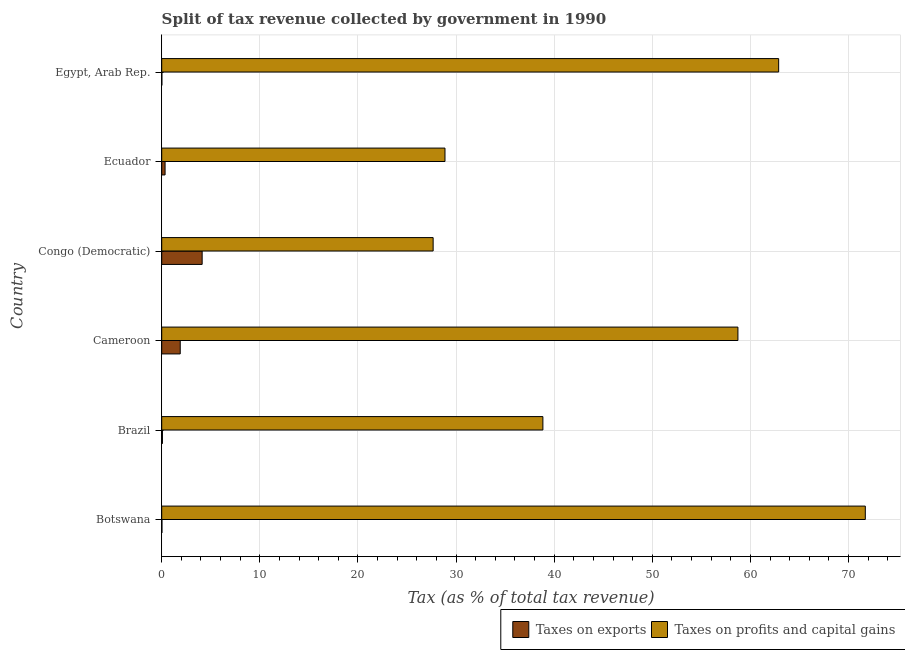Are the number of bars per tick equal to the number of legend labels?
Your answer should be very brief. Yes. How many bars are there on the 4th tick from the top?
Offer a very short reply. 2. What is the label of the 4th group of bars from the top?
Offer a very short reply. Cameroon. In how many cases, is the number of bars for a given country not equal to the number of legend labels?
Provide a succinct answer. 0. What is the percentage of revenue obtained from taxes on exports in Ecuador?
Provide a succinct answer. 0.34. Across all countries, what is the maximum percentage of revenue obtained from taxes on exports?
Your response must be concise. 4.12. Across all countries, what is the minimum percentage of revenue obtained from taxes on profits and capital gains?
Your answer should be very brief. 27.66. In which country was the percentage of revenue obtained from taxes on profits and capital gains maximum?
Your answer should be very brief. Botswana. In which country was the percentage of revenue obtained from taxes on exports minimum?
Provide a short and direct response. Egypt, Arab Rep. What is the total percentage of revenue obtained from taxes on profits and capital gains in the graph?
Ensure brevity in your answer.  288.69. What is the difference between the percentage of revenue obtained from taxes on exports in Congo (Democratic) and that in Ecuador?
Make the answer very short. 3.78. What is the difference between the percentage of revenue obtained from taxes on exports in Botswana and the percentage of revenue obtained from taxes on profits and capital gains in Ecuador?
Offer a terse response. -28.85. What is the average percentage of revenue obtained from taxes on exports per country?
Provide a succinct answer. 1.08. What is the difference between the percentage of revenue obtained from taxes on profits and capital gains and percentage of revenue obtained from taxes on exports in Congo (Democratic)?
Offer a terse response. 23.54. What is the ratio of the percentage of revenue obtained from taxes on profits and capital gains in Botswana to that in Congo (Democratic)?
Your response must be concise. 2.59. What is the difference between the highest and the second highest percentage of revenue obtained from taxes on exports?
Provide a succinct answer. 2.23. What is the difference between the highest and the lowest percentage of revenue obtained from taxes on profits and capital gains?
Your answer should be compact. 44.05. What does the 1st bar from the top in Egypt, Arab Rep. represents?
Provide a short and direct response. Taxes on profits and capital gains. What does the 1st bar from the bottom in Congo (Democratic) represents?
Ensure brevity in your answer.  Taxes on exports. Are all the bars in the graph horizontal?
Offer a terse response. Yes. How many countries are there in the graph?
Offer a very short reply. 6. What is the difference between two consecutive major ticks on the X-axis?
Provide a succinct answer. 10. Does the graph contain any zero values?
Your answer should be very brief. No. Where does the legend appear in the graph?
Provide a succinct answer. Bottom right. How many legend labels are there?
Give a very brief answer. 2. What is the title of the graph?
Your answer should be very brief. Split of tax revenue collected by government in 1990. What is the label or title of the X-axis?
Your answer should be compact. Tax (as % of total tax revenue). What is the label or title of the Y-axis?
Ensure brevity in your answer.  Country. What is the Tax (as % of total tax revenue) in Taxes on exports in Botswana?
Offer a very short reply. 0.02. What is the Tax (as % of total tax revenue) of Taxes on profits and capital gains in Botswana?
Provide a short and direct response. 71.71. What is the Tax (as % of total tax revenue) in Taxes on exports in Brazil?
Provide a short and direct response. 0.07. What is the Tax (as % of total tax revenue) of Taxes on profits and capital gains in Brazil?
Offer a terse response. 38.85. What is the Tax (as % of total tax revenue) of Taxes on exports in Cameroon?
Your answer should be compact. 1.89. What is the Tax (as % of total tax revenue) of Taxes on profits and capital gains in Cameroon?
Make the answer very short. 58.73. What is the Tax (as % of total tax revenue) of Taxes on exports in Congo (Democratic)?
Offer a terse response. 4.12. What is the Tax (as % of total tax revenue) in Taxes on profits and capital gains in Congo (Democratic)?
Give a very brief answer. 27.66. What is the Tax (as % of total tax revenue) in Taxes on exports in Ecuador?
Provide a succinct answer. 0.34. What is the Tax (as % of total tax revenue) in Taxes on profits and capital gains in Ecuador?
Provide a short and direct response. 28.87. What is the Tax (as % of total tax revenue) of Taxes on exports in Egypt, Arab Rep.?
Provide a succinct answer. 0.02. What is the Tax (as % of total tax revenue) of Taxes on profits and capital gains in Egypt, Arab Rep.?
Ensure brevity in your answer.  62.88. Across all countries, what is the maximum Tax (as % of total tax revenue) of Taxes on exports?
Provide a short and direct response. 4.12. Across all countries, what is the maximum Tax (as % of total tax revenue) in Taxes on profits and capital gains?
Offer a terse response. 71.71. Across all countries, what is the minimum Tax (as % of total tax revenue) in Taxes on exports?
Your response must be concise. 0.02. Across all countries, what is the minimum Tax (as % of total tax revenue) of Taxes on profits and capital gains?
Make the answer very short. 27.66. What is the total Tax (as % of total tax revenue) of Taxes on exports in the graph?
Make the answer very short. 6.46. What is the total Tax (as % of total tax revenue) in Taxes on profits and capital gains in the graph?
Your response must be concise. 288.69. What is the difference between the Tax (as % of total tax revenue) in Taxes on exports in Botswana and that in Brazil?
Your answer should be compact. -0.05. What is the difference between the Tax (as % of total tax revenue) in Taxes on profits and capital gains in Botswana and that in Brazil?
Your response must be concise. 32.86. What is the difference between the Tax (as % of total tax revenue) in Taxes on exports in Botswana and that in Cameroon?
Provide a short and direct response. -1.86. What is the difference between the Tax (as % of total tax revenue) in Taxes on profits and capital gains in Botswana and that in Cameroon?
Give a very brief answer. 12.98. What is the difference between the Tax (as % of total tax revenue) of Taxes on exports in Botswana and that in Congo (Democratic)?
Offer a terse response. -4.1. What is the difference between the Tax (as % of total tax revenue) in Taxes on profits and capital gains in Botswana and that in Congo (Democratic)?
Make the answer very short. 44.05. What is the difference between the Tax (as % of total tax revenue) in Taxes on exports in Botswana and that in Ecuador?
Give a very brief answer. -0.32. What is the difference between the Tax (as % of total tax revenue) in Taxes on profits and capital gains in Botswana and that in Ecuador?
Provide a short and direct response. 42.84. What is the difference between the Tax (as % of total tax revenue) of Taxes on exports in Botswana and that in Egypt, Arab Rep.?
Give a very brief answer. 0.01. What is the difference between the Tax (as % of total tax revenue) of Taxes on profits and capital gains in Botswana and that in Egypt, Arab Rep.?
Offer a terse response. 8.83. What is the difference between the Tax (as % of total tax revenue) of Taxes on exports in Brazil and that in Cameroon?
Make the answer very short. -1.81. What is the difference between the Tax (as % of total tax revenue) in Taxes on profits and capital gains in Brazil and that in Cameroon?
Give a very brief answer. -19.88. What is the difference between the Tax (as % of total tax revenue) of Taxes on exports in Brazil and that in Congo (Democratic)?
Your answer should be compact. -4.05. What is the difference between the Tax (as % of total tax revenue) in Taxes on profits and capital gains in Brazil and that in Congo (Democratic)?
Provide a succinct answer. 11.19. What is the difference between the Tax (as % of total tax revenue) in Taxes on exports in Brazil and that in Ecuador?
Your answer should be compact. -0.27. What is the difference between the Tax (as % of total tax revenue) in Taxes on profits and capital gains in Brazil and that in Ecuador?
Keep it short and to the point. 9.98. What is the difference between the Tax (as % of total tax revenue) in Taxes on exports in Brazil and that in Egypt, Arab Rep.?
Provide a short and direct response. 0.06. What is the difference between the Tax (as % of total tax revenue) in Taxes on profits and capital gains in Brazil and that in Egypt, Arab Rep.?
Keep it short and to the point. -24.03. What is the difference between the Tax (as % of total tax revenue) of Taxes on exports in Cameroon and that in Congo (Democratic)?
Your answer should be compact. -2.23. What is the difference between the Tax (as % of total tax revenue) in Taxes on profits and capital gains in Cameroon and that in Congo (Democratic)?
Provide a short and direct response. 31.06. What is the difference between the Tax (as % of total tax revenue) in Taxes on exports in Cameroon and that in Ecuador?
Ensure brevity in your answer.  1.54. What is the difference between the Tax (as % of total tax revenue) in Taxes on profits and capital gains in Cameroon and that in Ecuador?
Give a very brief answer. 29.86. What is the difference between the Tax (as % of total tax revenue) of Taxes on exports in Cameroon and that in Egypt, Arab Rep.?
Offer a very short reply. 1.87. What is the difference between the Tax (as % of total tax revenue) of Taxes on profits and capital gains in Cameroon and that in Egypt, Arab Rep.?
Offer a very short reply. -4.15. What is the difference between the Tax (as % of total tax revenue) in Taxes on exports in Congo (Democratic) and that in Ecuador?
Offer a very short reply. 3.78. What is the difference between the Tax (as % of total tax revenue) of Taxes on profits and capital gains in Congo (Democratic) and that in Ecuador?
Ensure brevity in your answer.  -1.21. What is the difference between the Tax (as % of total tax revenue) of Taxes on exports in Congo (Democratic) and that in Egypt, Arab Rep.?
Your answer should be compact. 4.11. What is the difference between the Tax (as % of total tax revenue) of Taxes on profits and capital gains in Congo (Democratic) and that in Egypt, Arab Rep.?
Your answer should be very brief. -35.21. What is the difference between the Tax (as % of total tax revenue) of Taxes on exports in Ecuador and that in Egypt, Arab Rep.?
Offer a terse response. 0.33. What is the difference between the Tax (as % of total tax revenue) of Taxes on profits and capital gains in Ecuador and that in Egypt, Arab Rep.?
Give a very brief answer. -34.01. What is the difference between the Tax (as % of total tax revenue) in Taxes on exports in Botswana and the Tax (as % of total tax revenue) in Taxes on profits and capital gains in Brazil?
Give a very brief answer. -38.83. What is the difference between the Tax (as % of total tax revenue) of Taxes on exports in Botswana and the Tax (as % of total tax revenue) of Taxes on profits and capital gains in Cameroon?
Your response must be concise. -58.7. What is the difference between the Tax (as % of total tax revenue) in Taxes on exports in Botswana and the Tax (as % of total tax revenue) in Taxes on profits and capital gains in Congo (Democratic)?
Make the answer very short. -27.64. What is the difference between the Tax (as % of total tax revenue) of Taxes on exports in Botswana and the Tax (as % of total tax revenue) of Taxes on profits and capital gains in Ecuador?
Offer a very short reply. -28.85. What is the difference between the Tax (as % of total tax revenue) in Taxes on exports in Botswana and the Tax (as % of total tax revenue) in Taxes on profits and capital gains in Egypt, Arab Rep.?
Offer a very short reply. -62.85. What is the difference between the Tax (as % of total tax revenue) of Taxes on exports in Brazil and the Tax (as % of total tax revenue) of Taxes on profits and capital gains in Cameroon?
Offer a terse response. -58.65. What is the difference between the Tax (as % of total tax revenue) in Taxes on exports in Brazil and the Tax (as % of total tax revenue) in Taxes on profits and capital gains in Congo (Democratic)?
Make the answer very short. -27.59. What is the difference between the Tax (as % of total tax revenue) of Taxes on exports in Brazil and the Tax (as % of total tax revenue) of Taxes on profits and capital gains in Ecuador?
Provide a succinct answer. -28.8. What is the difference between the Tax (as % of total tax revenue) in Taxes on exports in Brazil and the Tax (as % of total tax revenue) in Taxes on profits and capital gains in Egypt, Arab Rep.?
Your answer should be compact. -62.8. What is the difference between the Tax (as % of total tax revenue) in Taxes on exports in Cameroon and the Tax (as % of total tax revenue) in Taxes on profits and capital gains in Congo (Democratic)?
Provide a succinct answer. -25.78. What is the difference between the Tax (as % of total tax revenue) of Taxes on exports in Cameroon and the Tax (as % of total tax revenue) of Taxes on profits and capital gains in Ecuador?
Offer a very short reply. -26.98. What is the difference between the Tax (as % of total tax revenue) of Taxes on exports in Cameroon and the Tax (as % of total tax revenue) of Taxes on profits and capital gains in Egypt, Arab Rep.?
Keep it short and to the point. -60.99. What is the difference between the Tax (as % of total tax revenue) of Taxes on exports in Congo (Democratic) and the Tax (as % of total tax revenue) of Taxes on profits and capital gains in Ecuador?
Your answer should be compact. -24.75. What is the difference between the Tax (as % of total tax revenue) in Taxes on exports in Congo (Democratic) and the Tax (as % of total tax revenue) in Taxes on profits and capital gains in Egypt, Arab Rep.?
Ensure brevity in your answer.  -58.76. What is the difference between the Tax (as % of total tax revenue) in Taxes on exports in Ecuador and the Tax (as % of total tax revenue) in Taxes on profits and capital gains in Egypt, Arab Rep.?
Provide a short and direct response. -62.53. What is the average Tax (as % of total tax revenue) in Taxes on exports per country?
Offer a terse response. 1.08. What is the average Tax (as % of total tax revenue) of Taxes on profits and capital gains per country?
Make the answer very short. 48.12. What is the difference between the Tax (as % of total tax revenue) of Taxes on exports and Tax (as % of total tax revenue) of Taxes on profits and capital gains in Botswana?
Offer a terse response. -71.69. What is the difference between the Tax (as % of total tax revenue) of Taxes on exports and Tax (as % of total tax revenue) of Taxes on profits and capital gains in Brazil?
Your answer should be compact. -38.78. What is the difference between the Tax (as % of total tax revenue) in Taxes on exports and Tax (as % of total tax revenue) in Taxes on profits and capital gains in Cameroon?
Your response must be concise. -56.84. What is the difference between the Tax (as % of total tax revenue) in Taxes on exports and Tax (as % of total tax revenue) in Taxes on profits and capital gains in Congo (Democratic)?
Provide a succinct answer. -23.54. What is the difference between the Tax (as % of total tax revenue) in Taxes on exports and Tax (as % of total tax revenue) in Taxes on profits and capital gains in Ecuador?
Make the answer very short. -28.53. What is the difference between the Tax (as % of total tax revenue) in Taxes on exports and Tax (as % of total tax revenue) in Taxes on profits and capital gains in Egypt, Arab Rep.?
Offer a terse response. -62.86. What is the ratio of the Tax (as % of total tax revenue) in Taxes on exports in Botswana to that in Brazil?
Your answer should be very brief. 0.31. What is the ratio of the Tax (as % of total tax revenue) of Taxes on profits and capital gains in Botswana to that in Brazil?
Give a very brief answer. 1.85. What is the ratio of the Tax (as % of total tax revenue) in Taxes on exports in Botswana to that in Cameroon?
Make the answer very short. 0.01. What is the ratio of the Tax (as % of total tax revenue) in Taxes on profits and capital gains in Botswana to that in Cameroon?
Give a very brief answer. 1.22. What is the ratio of the Tax (as % of total tax revenue) of Taxes on exports in Botswana to that in Congo (Democratic)?
Keep it short and to the point. 0.01. What is the ratio of the Tax (as % of total tax revenue) in Taxes on profits and capital gains in Botswana to that in Congo (Democratic)?
Provide a succinct answer. 2.59. What is the ratio of the Tax (as % of total tax revenue) of Taxes on exports in Botswana to that in Ecuador?
Your response must be concise. 0.07. What is the ratio of the Tax (as % of total tax revenue) of Taxes on profits and capital gains in Botswana to that in Ecuador?
Your answer should be very brief. 2.48. What is the ratio of the Tax (as % of total tax revenue) in Taxes on exports in Botswana to that in Egypt, Arab Rep.?
Offer a very short reply. 1.44. What is the ratio of the Tax (as % of total tax revenue) of Taxes on profits and capital gains in Botswana to that in Egypt, Arab Rep.?
Keep it short and to the point. 1.14. What is the ratio of the Tax (as % of total tax revenue) in Taxes on exports in Brazil to that in Cameroon?
Provide a short and direct response. 0.04. What is the ratio of the Tax (as % of total tax revenue) of Taxes on profits and capital gains in Brazil to that in Cameroon?
Ensure brevity in your answer.  0.66. What is the ratio of the Tax (as % of total tax revenue) of Taxes on exports in Brazil to that in Congo (Democratic)?
Offer a terse response. 0.02. What is the ratio of the Tax (as % of total tax revenue) of Taxes on profits and capital gains in Brazil to that in Congo (Democratic)?
Your answer should be very brief. 1.4. What is the ratio of the Tax (as % of total tax revenue) in Taxes on exports in Brazil to that in Ecuador?
Give a very brief answer. 0.21. What is the ratio of the Tax (as % of total tax revenue) in Taxes on profits and capital gains in Brazil to that in Ecuador?
Provide a short and direct response. 1.35. What is the ratio of the Tax (as % of total tax revenue) of Taxes on exports in Brazil to that in Egypt, Arab Rep.?
Offer a terse response. 4.65. What is the ratio of the Tax (as % of total tax revenue) in Taxes on profits and capital gains in Brazil to that in Egypt, Arab Rep.?
Keep it short and to the point. 0.62. What is the ratio of the Tax (as % of total tax revenue) in Taxes on exports in Cameroon to that in Congo (Democratic)?
Your response must be concise. 0.46. What is the ratio of the Tax (as % of total tax revenue) of Taxes on profits and capital gains in Cameroon to that in Congo (Democratic)?
Your response must be concise. 2.12. What is the ratio of the Tax (as % of total tax revenue) in Taxes on exports in Cameroon to that in Ecuador?
Your response must be concise. 5.51. What is the ratio of the Tax (as % of total tax revenue) in Taxes on profits and capital gains in Cameroon to that in Ecuador?
Offer a terse response. 2.03. What is the ratio of the Tax (as % of total tax revenue) of Taxes on exports in Cameroon to that in Egypt, Arab Rep.?
Offer a terse response. 119.64. What is the ratio of the Tax (as % of total tax revenue) in Taxes on profits and capital gains in Cameroon to that in Egypt, Arab Rep.?
Make the answer very short. 0.93. What is the ratio of the Tax (as % of total tax revenue) in Taxes on exports in Congo (Democratic) to that in Ecuador?
Keep it short and to the point. 12.04. What is the ratio of the Tax (as % of total tax revenue) in Taxes on profits and capital gains in Congo (Democratic) to that in Ecuador?
Make the answer very short. 0.96. What is the ratio of the Tax (as % of total tax revenue) of Taxes on exports in Congo (Democratic) to that in Egypt, Arab Rep.?
Make the answer very short. 261.29. What is the ratio of the Tax (as % of total tax revenue) in Taxes on profits and capital gains in Congo (Democratic) to that in Egypt, Arab Rep.?
Make the answer very short. 0.44. What is the ratio of the Tax (as % of total tax revenue) of Taxes on exports in Ecuador to that in Egypt, Arab Rep.?
Your answer should be compact. 21.71. What is the ratio of the Tax (as % of total tax revenue) in Taxes on profits and capital gains in Ecuador to that in Egypt, Arab Rep.?
Your answer should be compact. 0.46. What is the difference between the highest and the second highest Tax (as % of total tax revenue) of Taxes on exports?
Your answer should be very brief. 2.23. What is the difference between the highest and the second highest Tax (as % of total tax revenue) in Taxes on profits and capital gains?
Your response must be concise. 8.83. What is the difference between the highest and the lowest Tax (as % of total tax revenue) of Taxes on exports?
Your response must be concise. 4.11. What is the difference between the highest and the lowest Tax (as % of total tax revenue) of Taxes on profits and capital gains?
Offer a very short reply. 44.05. 